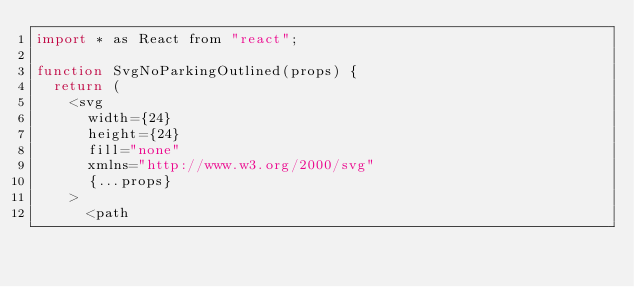<code> <loc_0><loc_0><loc_500><loc_500><_JavaScript_>import * as React from "react";

function SvgNoParkingOutlined(props) {
  return (
    <svg
      width={24}
      height={24}
      fill="none"
      xmlns="http://www.w3.org/2000/svg"
      {...props}
    >
      <path</code> 